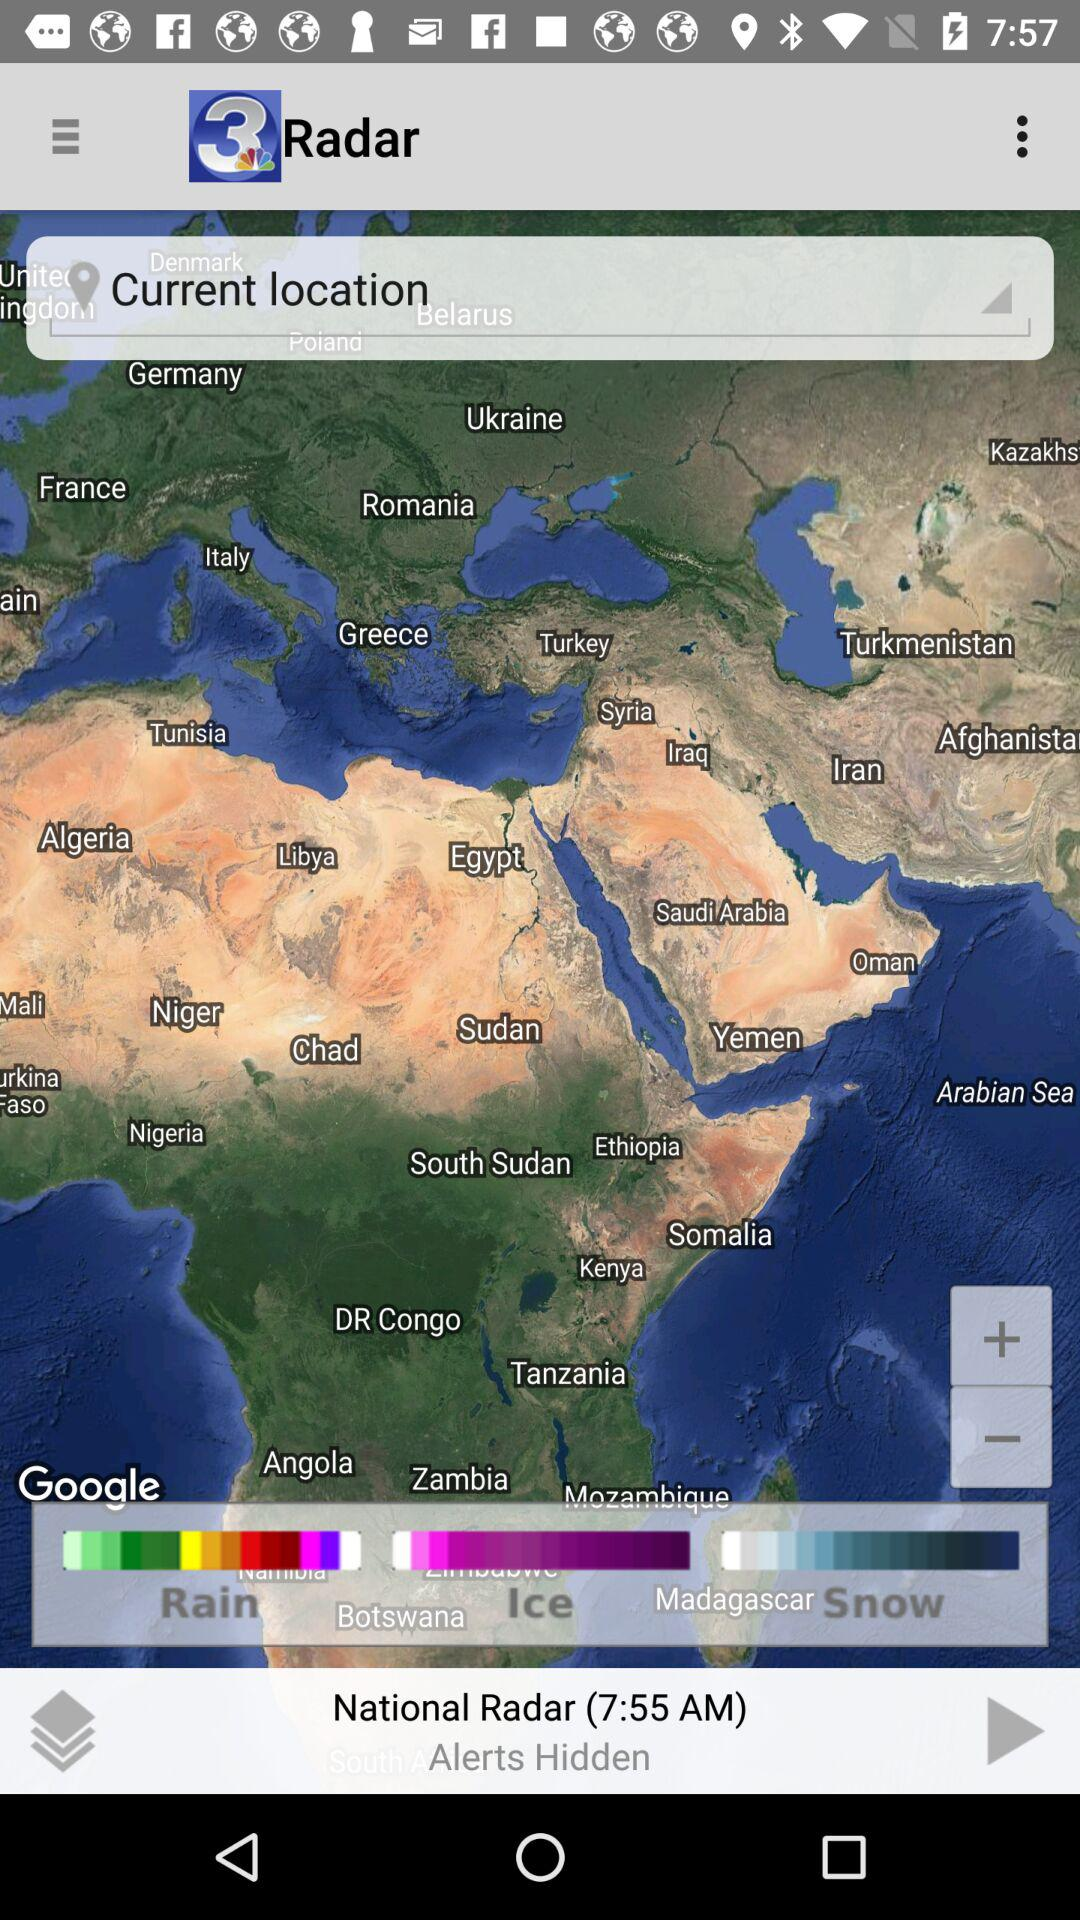What is the current location?
When the provided information is insufficient, respond with <no answer>. <no answer> 